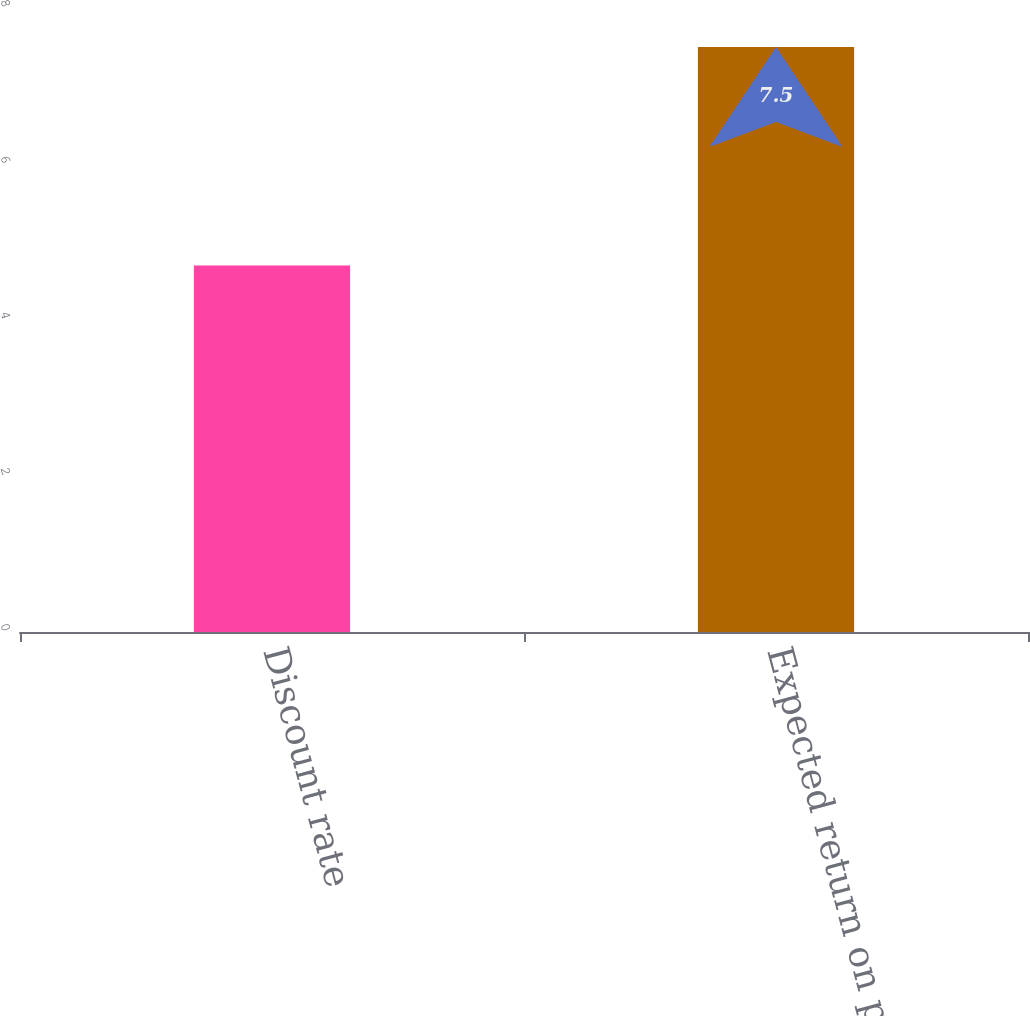<chart> <loc_0><loc_0><loc_500><loc_500><bar_chart><fcel>Discount rate<fcel>Expected return on plan assets<nl><fcel>4.7<fcel>7.5<nl></chart> 